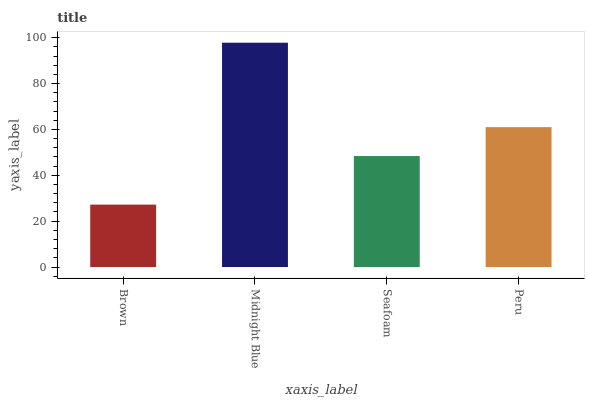Is Brown the minimum?
Answer yes or no. Yes. Is Midnight Blue the maximum?
Answer yes or no. Yes. Is Seafoam the minimum?
Answer yes or no. No. Is Seafoam the maximum?
Answer yes or no. No. Is Midnight Blue greater than Seafoam?
Answer yes or no. Yes. Is Seafoam less than Midnight Blue?
Answer yes or no. Yes. Is Seafoam greater than Midnight Blue?
Answer yes or no. No. Is Midnight Blue less than Seafoam?
Answer yes or no. No. Is Peru the high median?
Answer yes or no. Yes. Is Seafoam the low median?
Answer yes or no. Yes. Is Seafoam the high median?
Answer yes or no. No. Is Peru the low median?
Answer yes or no. No. 